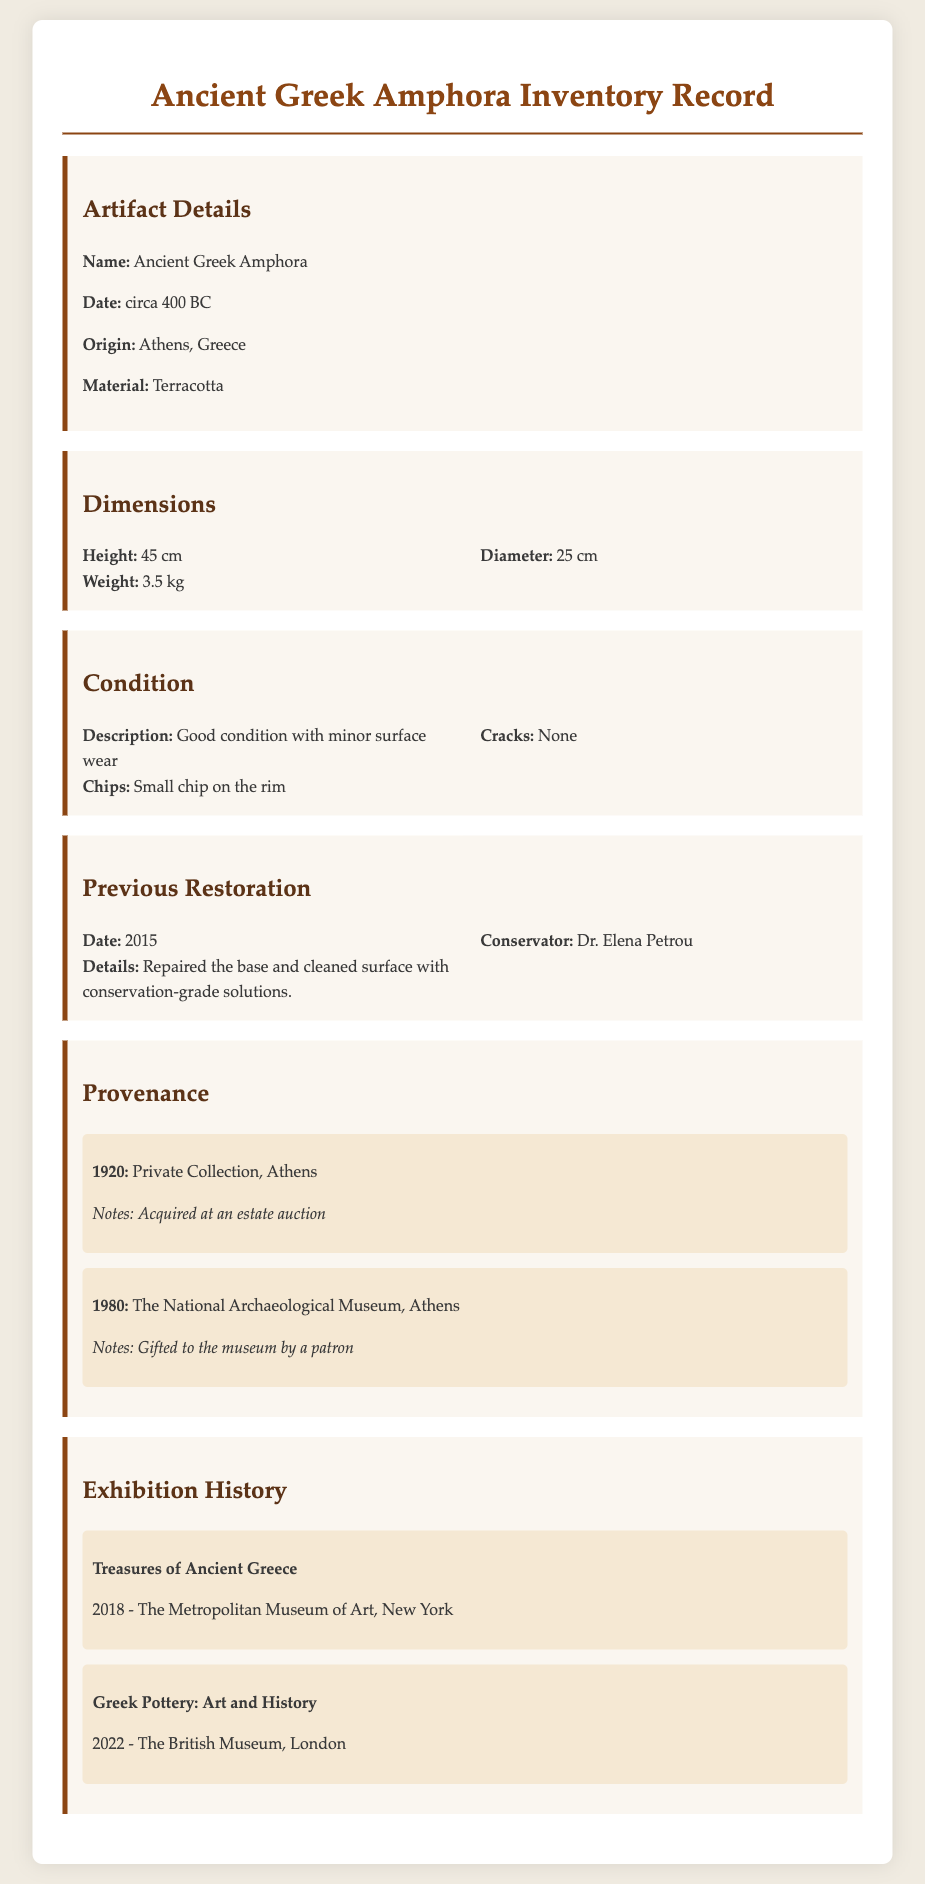What is the height of the amphora? The height is specified in the dimensions section of the document.
Answer: 45 cm What is the material of the artifact? The material is stated under the artifact details section.
Answer: Terracotta How many previous restorations has the amphora undergone? There is one restoration documented in the previous restoration section.
Answer: 1 What minor defect is mentioned in the condition section? The condition section lists details about the state of the amphora, including any defects.
Answer: Small chip on the rim Who was the conservator that performed restoration in 2015? The conservator's name is found in the previous restoration section.
Answer: Dr. Elena Petrou In what year was the amphora acquired at an estate auction? The provenance section lists the year the amphora was acquired.
Answer: 1920 What exhibition featured the amphora in 2018? The exhibition history section lists various exhibitions, including the mentioned year.
Answer: Treasures of Ancient Greece Which city is referenced as the origin of the amphora? The origin is provided in the artifact details section.
Answer: Athens, Greece What is the weight of the amphora? The weight is specified in the dimensions section of the document.
Answer: 3.5 kg 